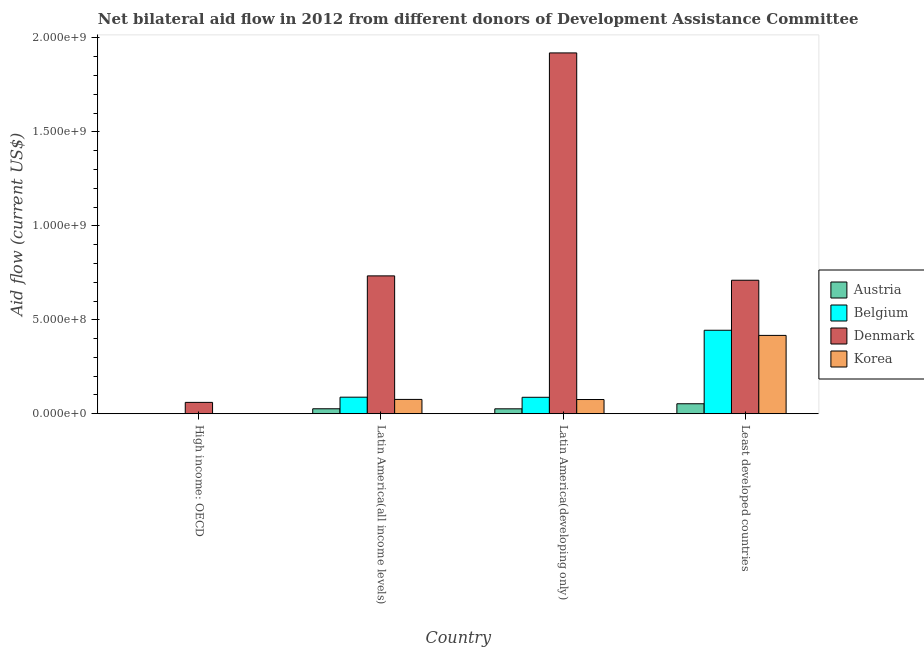How many different coloured bars are there?
Offer a very short reply. 4. Are the number of bars per tick equal to the number of legend labels?
Your answer should be compact. Yes. Are the number of bars on each tick of the X-axis equal?
Make the answer very short. Yes. How many bars are there on the 4th tick from the right?
Provide a succinct answer. 4. What is the label of the 1st group of bars from the left?
Provide a succinct answer. High income: OECD. In how many cases, is the number of bars for a given country not equal to the number of legend labels?
Your answer should be very brief. 0. What is the amount of aid given by denmark in High income: OECD?
Your answer should be very brief. 6.04e+07. Across all countries, what is the maximum amount of aid given by belgium?
Keep it short and to the point. 4.44e+08. Across all countries, what is the minimum amount of aid given by austria?
Provide a succinct answer. 2.90e+05. In which country was the amount of aid given by denmark maximum?
Offer a terse response. Latin America(developing only). In which country was the amount of aid given by austria minimum?
Keep it short and to the point. High income: OECD. What is the total amount of aid given by austria in the graph?
Keep it short and to the point. 1.06e+08. What is the difference between the amount of aid given by austria in Latin America(all income levels) and that in Latin America(developing only)?
Make the answer very short. 3.00e+05. What is the difference between the amount of aid given by korea in Latin America(all income levels) and the amount of aid given by belgium in Least developed countries?
Ensure brevity in your answer.  -3.68e+08. What is the average amount of aid given by korea per country?
Provide a succinct answer. 1.42e+08. What is the difference between the amount of aid given by austria and amount of aid given by belgium in High income: OECD?
Offer a terse response. -2.40e+05. In how many countries, is the amount of aid given by austria greater than 200000000 US$?
Provide a succinct answer. 0. What is the ratio of the amount of aid given by austria in Latin America(all income levels) to that in Least developed countries?
Offer a very short reply. 0.5. Is the difference between the amount of aid given by belgium in Latin America(developing only) and Least developed countries greater than the difference between the amount of aid given by austria in Latin America(developing only) and Least developed countries?
Offer a very short reply. No. What is the difference between the highest and the second highest amount of aid given by denmark?
Your answer should be compact. 1.19e+09. What is the difference between the highest and the lowest amount of aid given by austria?
Ensure brevity in your answer.  5.28e+07. What does the 1st bar from the left in Latin America(all income levels) represents?
Your response must be concise. Austria. What does the 1st bar from the right in Latin America(developing only) represents?
Offer a very short reply. Korea. Are all the bars in the graph horizontal?
Offer a terse response. No. How many countries are there in the graph?
Provide a short and direct response. 4. Where does the legend appear in the graph?
Your answer should be compact. Center right. How many legend labels are there?
Offer a terse response. 4. What is the title of the graph?
Give a very brief answer. Net bilateral aid flow in 2012 from different donors of Development Assistance Committee. Does "Financial sector" appear as one of the legend labels in the graph?
Ensure brevity in your answer.  No. What is the label or title of the Y-axis?
Offer a very short reply. Aid flow (current US$). What is the Aid flow (current US$) in Belgium in High income: OECD?
Make the answer very short. 5.30e+05. What is the Aid flow (current US$) of Denmark in High income: OECD?
Offer a terse response. 6.04e+07. What is the Aid flow (current US$) in Austria in Latin America(all income levels)?
Your answer should be very brief. 2.64e+07. What is the Aid flow (current US$) in Belgium in Latin America(all income levels)?
Your response must be concise. 8.82e+07. What is the Aid flow (current US$) of Denmark in Latin America(all income levels)?
Your answer should be compact. 7.34e+08. What is the Aid flow (current US$) of Korea in Latin America(all income levels)?
Your answer should be compact. 7.62e+07. What is the Aid flow (current US$) of Austria in Latin America(developing only)?
Offer a terse response. 2.62e+07. What is the Aid flow (current US$) in Belgium in Latin America(developing only)?
Keep it short and to the point. 8.76e+07. What is the Aid flow (current US$) in Denmark in Latin America(developing only)?
Offer a terse response. 1.92e+09. What is the Aid flow (current US$) in Korea in Latin America(developing only)?
Provide a succinct answer. 7.56e+07. What is the Aid flow (current US$) of Austria in Least developed countries?
Provide a succinct answer. 5.31e+07. What is the Aid flow (current US$) of Belgium in Least developed countries?
Offer a very short reply. 4.44e+08. What is the Aid flow (current US$) of Denmark in Least developed countries?
Give a very brief answer. 7.11e+08. What is the Aid flow (current US$) in Korea in Least developed countries?
Offer a very short reply. 4.17e+08. Across all countries, what is the maximum Aid flow (current US$) in Austria?
Offer a terse response. 5.31e+07. Across all countries, what is the maximum Aid flow (current US$) in Belgium?
Provide a succinct answer. 4.44e+08. Across all countries, what is the maximum Aid flow (current US$) in Denmark?
Provide a succinct answer. 1.92e+09. Across all countries, what is the maximum Aid flow (current US$) in Korea?
Offer a very short reply. 4.17e+08. Across all countries, what is the minimum Aid flow (current US$) of Austria?
Ensure brevity in your answer.  2.90e+05. Across all countries, what is the minimum Aid flow (current US$) of Belgium?
Provide a succinct answer. 5.30e+05. Across all countries, what is the minimum Aid flow (current US$) in Denmark?
Your response must be concise. 6.04e+07. Across all countries, what is the minimum Aid flow (current US$) of Korea?
Offer a terse response. 1.50e+05. What is the total Aid flow (current US$) in Austria in the graph?
Give a very brief answer. 1.06e+08. What is the total Aid flow (current US$) of Belgium in the graph?
Provide a succinct answer. 6.21e+08. What is the total Aid flow (current US$) of Denmark in the graph?
Your answer should be very brief. 3.43e+09. What is the total Aid flow (current US$) in Korea in the graph?
Ensure brevity in your answer.  5.69e+08. What is the difference between the Aid flow (current US$) of Austria in High income: OECD and that in Latin America(all income levels)?
Provide a short and direct response. -2.62e+07. What is the difference between the Aid flow (current US$) in Belgium in High income: OECD and that in Latin America(all income levels)?
Provide a short and direct response. -8.76e+07. What is the difference between the Aid flow (current US$) of Denmark in High income: OECD and that in Latin America(all income levels)?
Ensure brevity in your answer.  -6.73e+08. What is the difference between the Aid flow (current US$) of Korea in High income: OECD and that in Latin America(all income levels)?
Provide a succinct answer. -7.60e+07. What is the difference between the Aid flow (current US$) of Austria in High income: OECD and that in Latin America(developing only)?
Ensure brevity in your answer.  -2.59e+07. What is the difference between the Aid flow (current US$) in Belgium in High income: OECD and that in Latin America(developing only)?
Provide a short and direct response. -8.71e+07. What is the difference between the Aid flow (current US$) of Denmark in High income: OECD and that in Latin America(developing only)?
Keep it short and to the point. -1.86e+09. What is the difference between the Aid flow (current US$) in Korea in High income: OECD and that in Latin America(developing only)?
Offer a very short reply. -7.55e+07. What is the difference between the Aid flow (current US$) in Austria in High income: OECD and that in Least developed countries?
Your answer should be very brief. -5.28e+07. What is the difference between the Aid flow (current US$) in Belgium in High income: OECD and that in Least developed countries?
Provide a succinct answer. -4.44e+08. What is the difference between the Aid flow (current US$) of Denmark in High income: OECD and that in Least developed countries?
Offer a terse response. -6.50e+08. What is the difference between the Aid flow (current US$) of Korea in High income: OECD and that in Least developed countries?
Provide a short and direct response. -4.17e+08. What is the difference between the Aid flow (current US$) in Austria in Latin America(all income levels) and that in Latin America(developing only)?
Give a very brief answer. 3.00e+05. What is the difference between the Aid flow (current US$) of Belgium in Latin America(all income levels) and that in Latin America(developing only)?
Offer a very short reply. 5.80e+05. What is the difference between the Aid flow (current US$) in Denmark in Latin America(all income levels) and that in Latin America(developing only)?
Offer a terse response. -1.19e+09. What is the difference between the Aid flow (current US$) in Korea in Latin America(all income levels) and that in Latin America(developing only)?
Ensure brevity in your answer.  5.70e+05. What is the difference between the Aid flow (current US$) in Austria in Latin America(all income levels) and that in Least developed countries?
Your answer should be compact. -2.67e+07. What is the difference between the Aid flow (current US$) of Belgium in Latin America(all income levels) and that in Least developed countries?
Offer a terse response. -3.56e+08. What is the difference between the Aid flow (current US$) of Denmark in Latin America(all income levels) and that in Least developed countries?
Provide a short and direct response. 2.32e+07. What is the difference between the Aid flow (current US$) in Korea in Latin America(all income levels) and that in Least developed countries?
Your answer should be very brief. -3.41e+08. What is the difference between the Aid flow (current US$) of Austria in Latin America(developing only) and that in Least developed countries?
Your response must be concise. -2.70e+07. What is the difference between the Aid flow (current US$) of Belgium in Latin America(developing only) and that in Least developed countries?
Make the answer very short. -3.57e+08. What is the difference between the Aid flow (current US$) of Denmark in Latin America(developing only) and that in Least developed countries?
Your response must be concise. 1.21e+09. What is the difference between the Aid flow (current US$) of Korea in Latin America(developing only) and that in Least developed countries?
Give a very brief answer. -3.41e+08. What is the difference between the Aid flow (current US$) in Austria in High income: OECD and the Aid flow (current US$) in Belgium in Latin America(all income levels)?
Ensure brevity in your answer.  -8.79e+07. What is the difference between the Aid flow (current US$) of Austria in High income: OECD and the Aid flow (current US$) of Denmark in Latin America(all income levels)?
Your response must be concise. -7.33e+08. What is the difference between the Aid flow (current US$) of Austria in High income: OECD and the Aid flow (current US$) of Korea in Latin America(all income levels)?
Your answer should be compact. -7.59e+07. What is the difference between the Aid flow (current US$) of Belgium in High income: OECD and the Aid flow (current US$) of Denmark in Latin America(all income levels)?
Provide a succinct answer. -7.33e+08. What is the difference between the Aid flow (current US$) in Belgium in High income: OECD and the Aid flow (current US$) in Korea in Latin America(all income levels)?
Your answer should be very brief. -7.57e+07. What is the difference between the Aid flow (current US$) in Denmark in High income: OECD and the Aid flow (current US$) in Korea in Latin America(all income levels)?
Ensure brevity in your answer.  -1.58e+07. What is the difference between the Aid flow (current US$) in Austria in High income: OECD and the Aid flow (current US$) in Belgium in Latin America(developing only)?
Make the answer very short. -8.73e+07. What is the difference between the Aid flow (current US$) in Austria in High income: OECD and the Aid flow (current US$) in Denmark in Latin America(developing only)?
Ensure brevity in your answer.  -1.92e+09. What is the difference between the Aid flow (current US$) in Austria in High income: OECD and the Aid flow (current US$) in Korea in Latin America(developing only)?
Make the answer very short. -7.53e+07. What is the difference between the Aid flow (current US$) of Belgium in High income: OECD and the Aid flow (current US$) of Denmark in Latin America(developing only)?
Your response must be concise. -1.92e+09. What is the difference between the Aid flow (current US$) in Belgium in High income: OECD and the Aid flow (current US$) in Korea in Latin America(developing only)?
Give a very brief answer. -7.51e+07. What is the difference between the Aid flow (current US$) of Denmark in High income: OECD and the Aid flow (current US$) of Korea in Latin America(developing only)?
Your answer should be very brief. -1.52e+07. What is the difference between the Aid flow (current US$) of Austria in High income: OECD and the Aid flow (current US$) of Belgium in Least developed countries?
Provide a short and direct response. -4.44e+08. What is the difference between the Aid flow (current US$) in Austria in High income: OECD and the Aid flow (current US$) in Denmark in Least developed countries?
Offer a terse response. -7.10e+08. What is the difference between the Aid flow (current US$) in Austria in High income: OECD and the Aid flow (current US$) in Korea in Least developed countries?
Provide a succinct answer. -4.17e+08. What is the difference between the Aid flow (current US$) of Belgium in High income: OECD and the Aid flow (current US$) of Denmark in Least developed countries?
Provide a short and direct response. -7.10e+08. What is the difference between the Aid flow (current US$) of Belgium in High income: OECD and the Aid flow (current US$) of Korea in Least developed countries?
Give a very brief answer. -4.16e+08. What is the difference between the Aid flow (current US$) of Denmark in High income: OECD and the Aid flow (current US$) of Korea in Least developed countries?
Ensure brevity in your answer.  -3.57e+08. What is the difference between the Aid flow (current US$) of Austria in Latin America(all income levels) and the Aid flow (current US$) of Belgium in Latin America(developing only)?
Your response must be concise. -6.11e+07. What is the difference between the Aid flow (current US$) in Austria in Latin America(all income levels) and the Aid flow (current US$) in Denmark in Latin America(developing only)?
Give a very brief answer. -1.89e+09. What is the difference between the Aid flow (current US$) of Austria in Latin America(all income levels) and the Aid flow (current US$) of Korea in Latin America(developing only)?
Your answer should be compact. -4.92e+07. What is the difference between the Aid flow (current US$) in Belgium in Latin America(all income levels) and the Aid flow (current US$) in Denmark in Latin America(developing only)?
Offer a very short reply. -1.83e+09. What is the difference between the Aid flow (current US$) in Belgium in Latin America(all income levels) and the Aid flow (current US$) in Korea in Latin America(developing only)?
Offer a terse response. 1.25e+07. What is the difference between the Aid flow (current US$) in Denmark in Latin America(all income levels) and the Aid flow (current US$) in Korea in Latin America(developing only)?
Your answer should be compact. 6.58e+08. What is the difference between the Aid flow (current US$) of Austria in Latin America(all income levels) and the Aid flow (current US$) of Belgium in Least developed countries?
Provide a short and direct response. -4.18e+08. What is the difference between the Aid flow (current US$) in Austria in Latin America(all income levels) and the Aid flow (current US$) in Denmark in Least developed countries?
Make the answer very short. -6.84e+08. What is the difference between the Aid flow (current US$) in Austria in Latin America(all income levels) and the Aid flow (current US$) in Korea in Least developed countries?
Your answer should be very brief. -3.91e+08. What is the difference between the Aid flow (current US$) in Belgium in Latin America(all income levels) and the Aid flow (current US$) in Denmark in Least developed countries?
Offer a very short reply. -6.22e+08. What is the difference between the Aid flow (current US$) in Belgium in Latin America(all income levels) and the Aid flow (current US$) in Korea in Least developed countries?
Offer a very short reply. -3.29e+08. What is the difference between the Aid flow (current US$) of Denmark in Latin America(all income levels) and the Aid flow (current US$) of Korea in Least developed countries?
Your answer should be very brief. 3.17e+08. What is the difference between the Aid flow (current US$) in Austria in Latin America(developing only) and the Aid flow (current US$) in Belgium in Least developed countries?
Your answer should be compact. -4.18e+08. What is the difference between the Aid flow (current US$) in Austria in Latin America(developing only) and the Aid flow (current US$) in Denmark in Least developed countries?
Give a very brief answer. -6.84e+08. What is the difference between the Aid flow (current US$) of Austria in Latin America(developing only) and the Aid flow (current US$) of Korea in Least developed countries?
Provide a short and direct response. -3.91e+08. What is the difference between the Aid flow (current US$) of Belgium in Latin America(developing only) and the Aid flow (current US$) of Denmark in Least developed countries?
Offer a terse response. -6.23e+08. What is the difference between the Aid flow (current US$) of Belgium in Latin America(developing only) and the Aid flow (current US$) of Korea in Least developed countries?
Ensure brevity in your answer.  -3.29e+08. What is the difference between the Aid flow (current US$) of Denmark in Latin America(developing only) and the Aid flow (current US$) of Korea in Least developed countries?
Your response must be concise. 1.50e+09. What is the average Aid flow (current US$) in Austria per country?
Offer a very short reply. 2.65e+07. What is the average Aid flow (current US$) in Belgium per country?
Your answer should be compact. 1.55e+08. What is the average Aid flow (current US$) in Denmark per country?
Ensure brevity in your answer.  8.56e+08. What is the average Aid flow (current US$) of Korea per country?
Give a very brief answer. 1.42e+08. What is the difference between the Aid flow (current US$) of Austria and Aid flow (current US$) of Denmark in High income: OECD?
Ensure brevity in your answer.  -6.01e+07. What is the difference between the Aid flow (current US$) in Belgium and Aid flow (current US$) in Denmark in High income: OECD?
Offer a very short reply. -5.99e+07. What is the difference between the Aid flow (current US$) in Denmark and Aid flow (current US$) in Korea in High income: OECD?
Provide a succinct answer. 6.03e+07. What is the difference between the Aid flow (current US$) in Austria and Aid flow (current US$) in Belgium in Latin America(all income levels)?
Provide a succinct answer. -6.17e+07. What is the difference between the Aid flow (current US$) in Austria and Aid flow (current US$) in Denmark in Latin America(all income levels)?
Your response must be concise. -7.07e+08. What is the difference between the Aid flow (current US$) in Austria and Aid flow (current US$) in Korea in Latin America(all income levels)?
Provide a short and direct response. -4.98e+07. What is the difference between the Aid flow (current US$) of Belgium and Aid flow (current US$) of Denmark in Latin America(all income levels)?
Make the answer very short. -6.46e+08. What is the difference between the Aid flow (current US$) of Belgium and Aid flow (current US$) of Korea in Latin America(all income levels)?
Your response must be concise. 1.20e+07. What is the difference between the Aid flow (current US$) in Denmark and Aid flow (current US$) in Korea in Latin America(all income levels)?
Provide a succinct answer. 6.58e+08. What is the difference between the Aid flow (current US$) in Austria and Aid flow (current US$) in Belgium in Latin America(developing only)?
Give a very brief answer. -6.14e+07. What is the difference between the Aid flow (current US$) of Austria and Aid flow (current US$) of Denmark in Latin America(developing only)?
Your answer should be very brief. -1.89e+09. What is the difference between the Aid flow (current US$) of Austria and Aid flow (current US$) of Korea in Latin America(developing only)?
Your answer should be compact. -4.95e+07. What is the difference between the Aid flow (current US$) in Belgium and Aid flow (current US$) in Denmark in Latin America(developing only)?
Give a very brief answer. -1.83e+09. What is the difference between the Aid flow (current US$) in Belgium and Aid flow (current US$) in Korea in Latin America(developing only)?
Offer a terse response. 1.20e+07. What is the difference between the Aid flow (current US$) of Denmark and Aid flow (current US$) of Korea in Latin America(developing only)?
Your answer should be compact. 1.84e+09. What is the difference between the Aid flow (current US$) in Austria and Aid flow (current US$) in Belgium in Least developed countries?
Keep it short and to the point. -3.91e+08. What is the difference between the Aid flow (current US$) in Austria and Aid flow (current US$) in Denmark in Least developed countries?
Provide a short and direct response. -6.57e+08. What is the difference between the Aid flow (current US$) of Austria and Aid flow (current US$) of Korea in Least developed countries?
Ensure brevity in your answer.  -3.64e+08. What is the difference between the Aid flow (current US$) of Belgium and Aid flow (current US$) of Denmark in Least developed countries?
Keep it short and to the point. -2.66e+08. What is the difference between the Aid flow (current US$) in Belgium and Aid flow (current US$) in Korea in Least developed countries?
Your answer should be compact. 2.73e+07. What is the difference between the Aid flow (current US$) in Denmark and Aid flow (current US$) in Korea in Least developed countries?
Your response must be concise. 2.94e+08. What is the ratio of the Aid flow (current US$) in Austria in High income: OECD to that in Latin America(all income levels)?
Make the answer very short. 0.01. What is the ratio of the Aid flow (current US$) in Belgium in High income: OECD to that in Latin America(all income levels)?
Provide a succinct answer. 0.01. What is the ratio of the Aid flow (current US$) of Denmark in High income: OECD to that in Latin America(all income levels)?
Offer a very short reply. 0.08. What is the ratio of the Aid flow (current US$) in Korea in High income: OECD to that in Latin America(all income levels)?
Keep it short and to the point. 0. What is the ratio of the Aid flow (current US$) of Austria in High income: OECD to that in Latin America(developing only)?
Your answer should be compact. 0.01. What is the ratio of the Aid flow (current US$) in Belgium in High income: OECD to that in Latin America(developing only)?
Make the answer very short. 0.01. What is the ratio of the Aid flow (current US$) of Denmark in High income: OECD to that in Latin America(developing only)?
Offer a terse response. 0.03. What is the ratio of the Aid flow (current US$) in Korea in High income: OECD to that in Latin America(developing only)?
Your answer should be very brief. 0. What is the ratio of the Aid flow (current US$) of Austria in High income: OECD to that in Least developed countries?
Your response must be concise. 0.01. What is the ratio of the Aid flow (current US$) of Belgium in High income: OECD to that in Least developed countries?
Your answer should be compact. 0. What is the ratio of the Aid flow (current US$) of Denmark in High income: OECD to that in Least developed countries?
Give a very brief answer. 0.09. What is the ratio of the Aid flow (current US$) of Korea in High income: OECD to that in Least developed countries?
Keep it short and to the point. 0. What is the ratio of the Aid flow (current US$) in Austria in Latin America(all income levels) to that in Latin America(developing only)?
Offer a very short reply. 1.01. What is the ratio of the Aid flow (current US$) of Belgium in Latin America(all income levels) to that in Latin America(developing only)?
Offer a terse response. 1.01. What is the ratio of the Aid flow (current US$) of Denmark in Latin America(all income levels) to that in Latin America(developing only)?
Ensure brevity in your answer.  0.38. What is the ratio of the Aid flow (current US$) in Korea in Latin America(all income levels) to that in Latin America(developing only)?
Your response must be concise. 1.01. What is the ratio of the Aid flow (current US$) of Austria in Latin America(all income levels) to that in Least developed countries?
Provide a succinct answer. 0.5. What is the ratio of the Aid flow (current US$) of Belgium in Latin America(all income levels) to that in Least developed countries?
Give a very brief answer. 0.2. What is the ratio of the Aid flow (current US$) of Denmark in Latin America(all income levels) to that in Least developed countries?
Your answer should be compact. 1.03. What is the ratio of the Aid flow (current US$) in Korea in Latin America(all income levels) to that in Least developed countries?
Provide a short and direct response. 0.18. What is the ratio of the Aid flow (current US$) of Austria in Latin America(developing only) to that in Least developed countries?
Make the answer very short. 0.49. What is the ratio of the Aid flow (current US$) of Belgium in Latin America(developing only) to that in Least developed countries?
Provide a short and direct response. 0.2. What is the ratio of the Aid flow (current US$) in Denmark in Latin America(developing only) to that in Least developed countries?
Offer a very short reply. 2.7. What is the ratio of the Aid flow (current US$) in Korea in Latin America(developing only) to that in Least developed countries?
Provide a succinct answer. 0.18. What is the difference between the highest and the second highest Aid flow (current US$) in Austria?
Ensure brevity in your answer.  2.67e+07. What is the difference between the highest and the second highest Aid flow (current US$) of Belgium?
Make the answer very short. 3.56e+08. What is the difference between the highest and the second highest Aid flow (current US$) of Denmark?
Keep it short and to the point. 1.19e+09. What is the difference between the highest and the second highest Aid flow (current US$) of Korea?
Offer a very short reply. 3.41e+08. What is the difference between the highest and the lowest Aid flow (current US$) of Austria?
Provide a succinct answer. 5.28e+07. What is the difference between the highest and the lowest Aid flow (current US$) in Belgium?
Make the answer very short. 4.44e+08. What is the difference between the highest and the lowest Aid flow (current US$) of Denmark?
Your response must be concise. 1.86e+09. What is the difference between the highest and the lowest Aid flow (current US$) of Korea?
Give a very brief answer. 4.17e+08. 